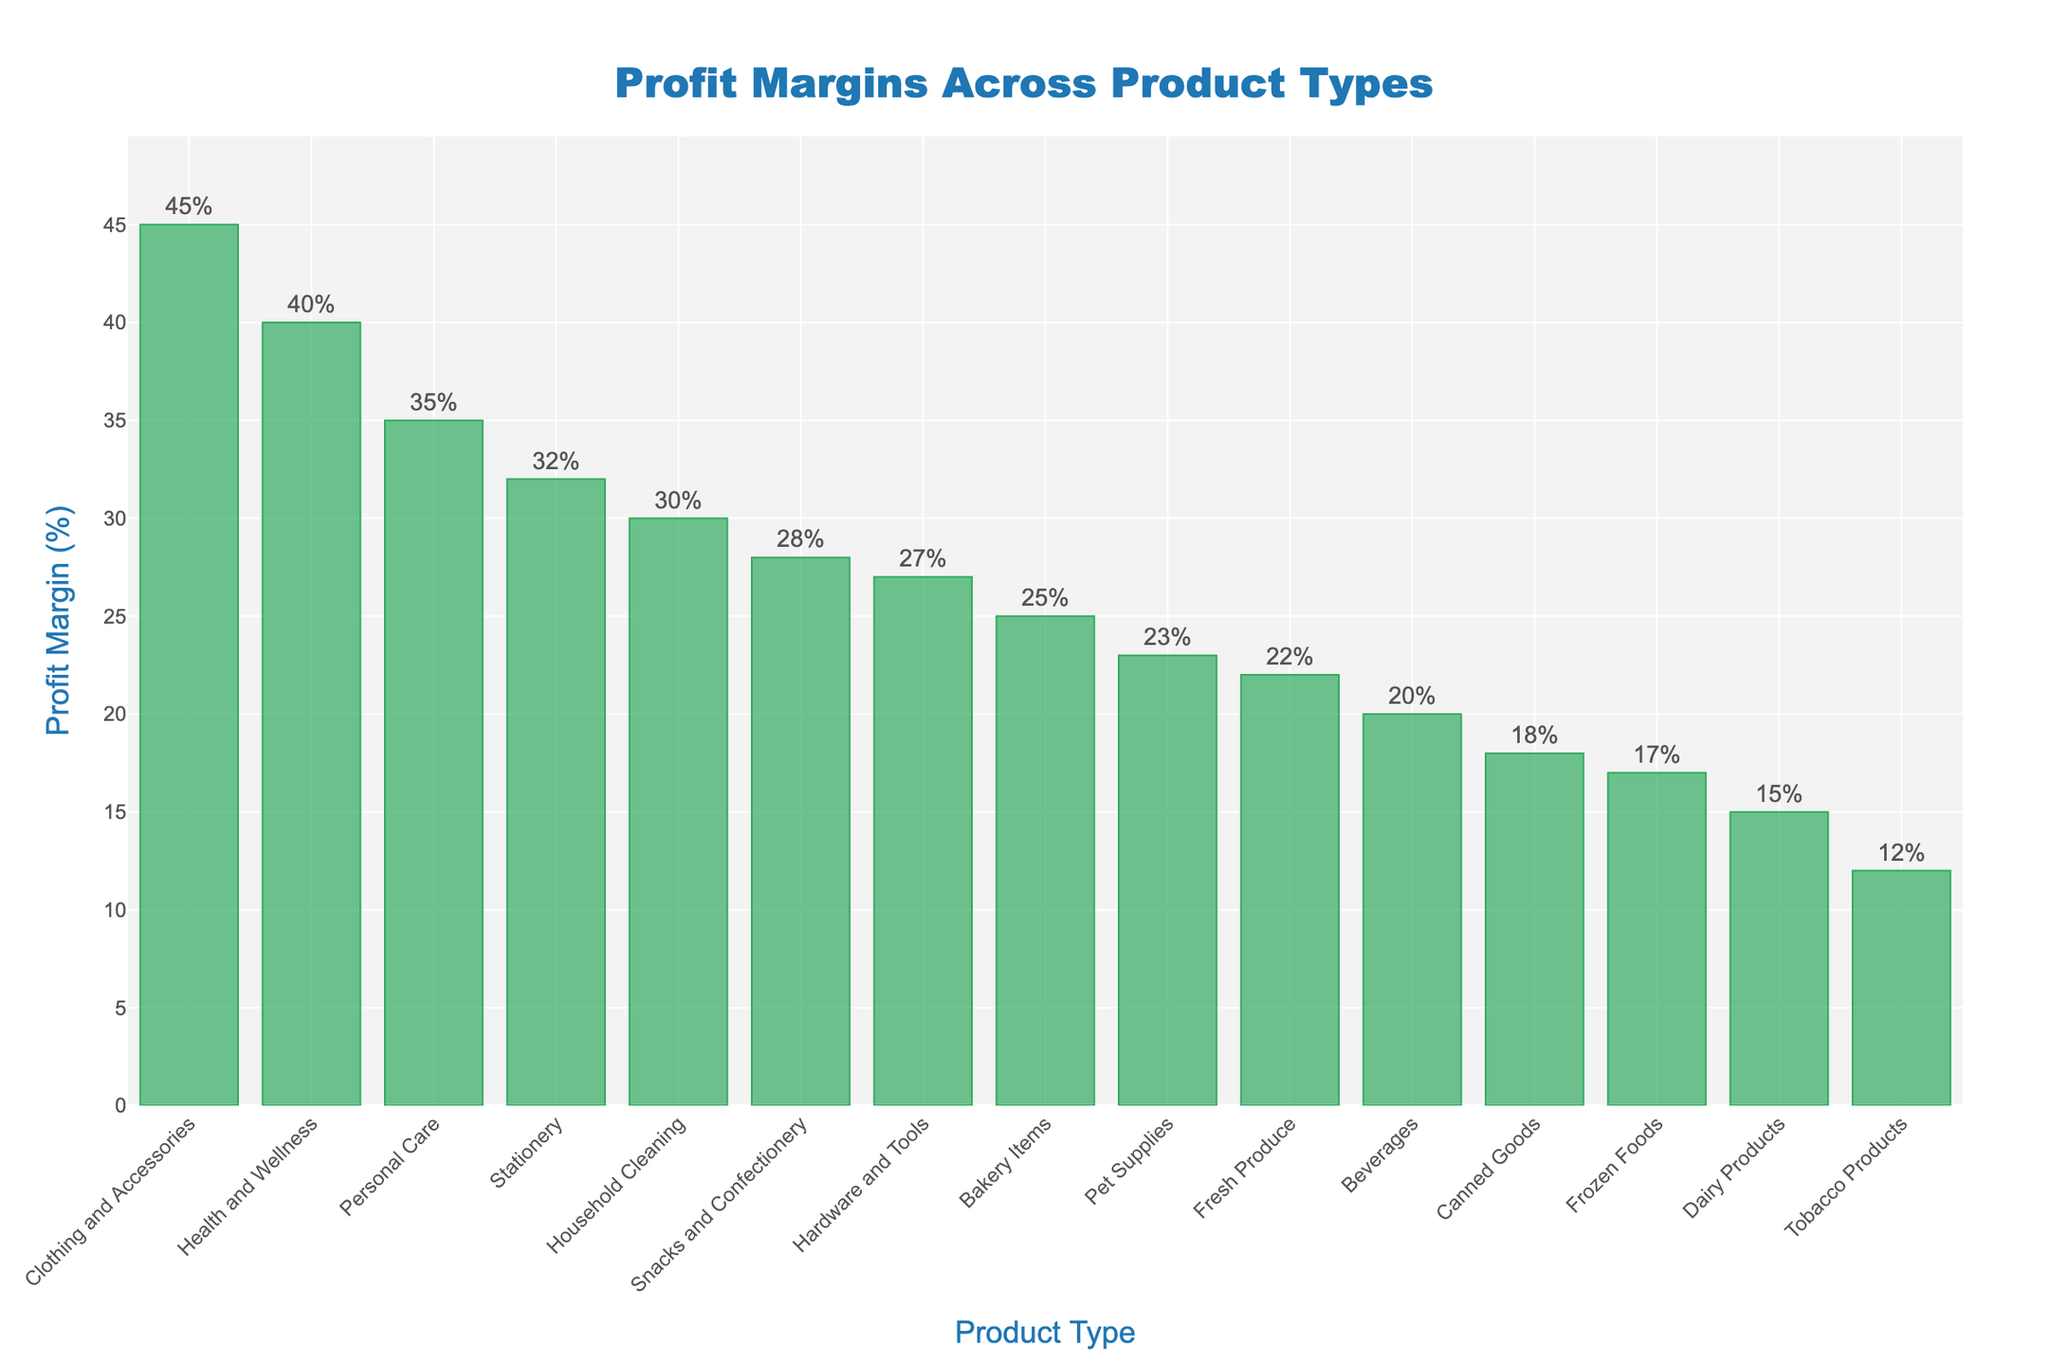What is the product type with the highest profit margin? By looking at the heights of the bars, the product type with the highest bar represents the highest profit margin, which is "Clothing and Accessories" with 45%.
Answer: Clothing and Accessories Which product type has a higher profit margin, Fresh Produce or Frozen Foods? Compare the height of the bars for "Fresh Produce" and "Frozen Foods". "Fresh Produce" has a profit margin of 22%, while "Frozen Foods" has 17%. Therefore, "Fresh Produce" has a higher profit margin.
Answer: Fresh Produce What is the difference in profit margin between Personal Care and Tobacco Products? The profit margin for Personal Care is 35%, and for Tobacco Products, it is 12%. Subtract the profit margin of Tobacco Products from Personal Care to find the difference: 35% - 12% = 23%.
Answer: 23% What is the median profit margin among all product types? To find the median profit margin, list all profit margins in ascending order: 12, 15, 17, 18, 20, 22, 23, 25, 27, 28, 30, 32, 35, 40, 45. The median value is the one in the middle of this ordered list, which is the 8th value: 25%.
Answer: 25% Which three product types have the smallest profit margins? Look at the heights of the bars and find the three with the smallest values: "Tobacco Products" (12%), "Dairy Products" (15%), and "Frozen Foods" (17%).
Answer: Tobacco Products, Dairy Products, Frozen Foods How much higher is the profit margin for Household Cleaning compared to Pet Supplies? Household Cleaning has a profit margin of 30%, and Pet Supplies have 23%. Subtract the profit margin of Pet Supplies from Household Cleaning to find the difference: 30% - 23% = 7%.
Answer: 7% What's the average profit margin of the top five product types? The top five product types by profit margin are "Clothing and Accessories" (45%), "Health and Wellness" (40%), "Personal Care" (35%), "Stationery" (32%), and "Household Cleaning" (30%). Calculate their average by adding the profit margins and dividing by 5: (45% + 40% + 35% + 32% + 30%) / 5 = 36.4%.
Answer: 36.4% Is there any product type with a profit margin equal to 20%? By inspecting the heights of the bars, we see that "Beverages" has a bar that reaches 20%, making it the product type with a profit margin of 20%.
Answer: Beverages Which product types have a profit margin of at least 30%? Identify the bars that reach or exceed the 30% value: "Household Cleaning" (30%), "Personal Care" (35%), "Stationery" (32%), "Health and Wellness" (40%), and "Clothing and Accessories" (45%).
Answer: Household Cleaning, Personal Care, Stationery, Health and Wellness, Clothing and Accessories How many product types have profit margins greater than 25%? Count all the bars with profit margins above 25%: "Personal Care" (35%), "Snacks and Confectionery" (28%), "Stationery" (32%), "Hardware and Tools" (27%), "Health and Wellness" (40%), and "Clothing and Accessories" (45%). There are six such product types.
Answer: 6 